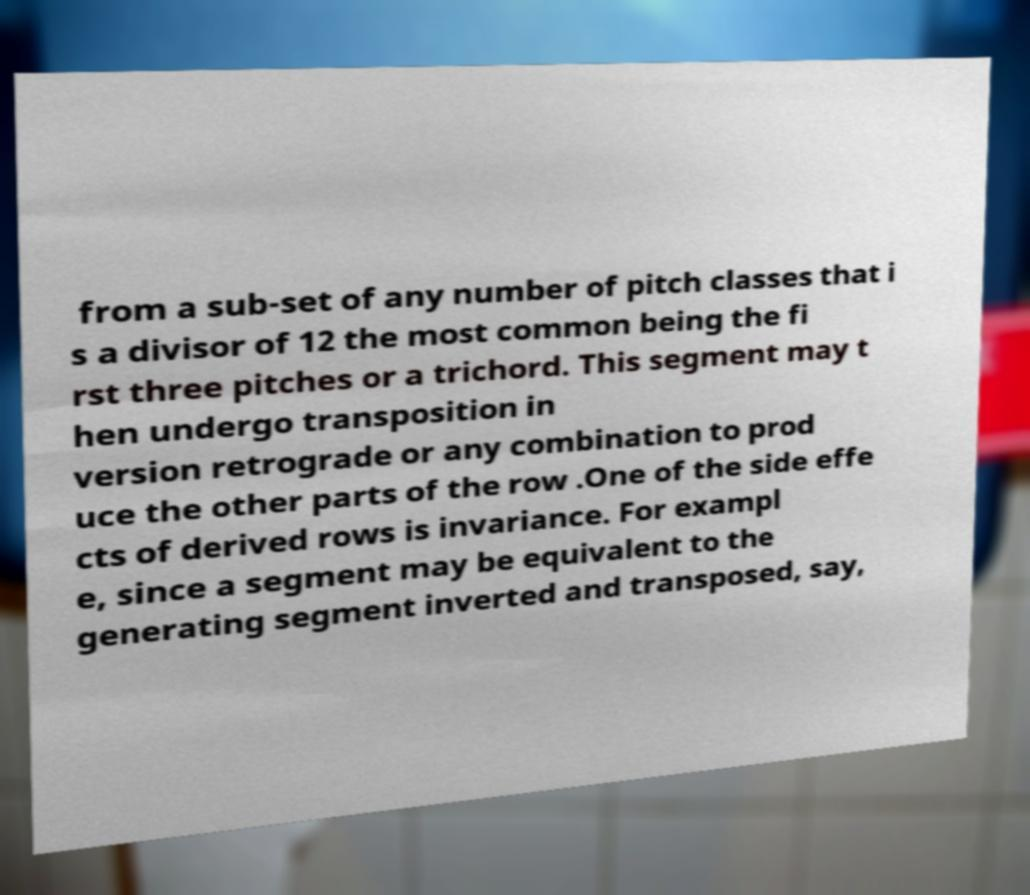There's text embedded in this image that I need extracted. Can you transcribe it verbatim? from a sub-set of any number of pitch classes that i s a divisor of 12 the most common being the fi rst three pitches or a trichord. This segment may t hen undergo transposition in version retrograde or any combination to prod uce the other parts of the row .One of the side effe cts of derived rows is invariance. For exampl e, since a segment may be equivalent to the generating segment inverted and transposed, say, 